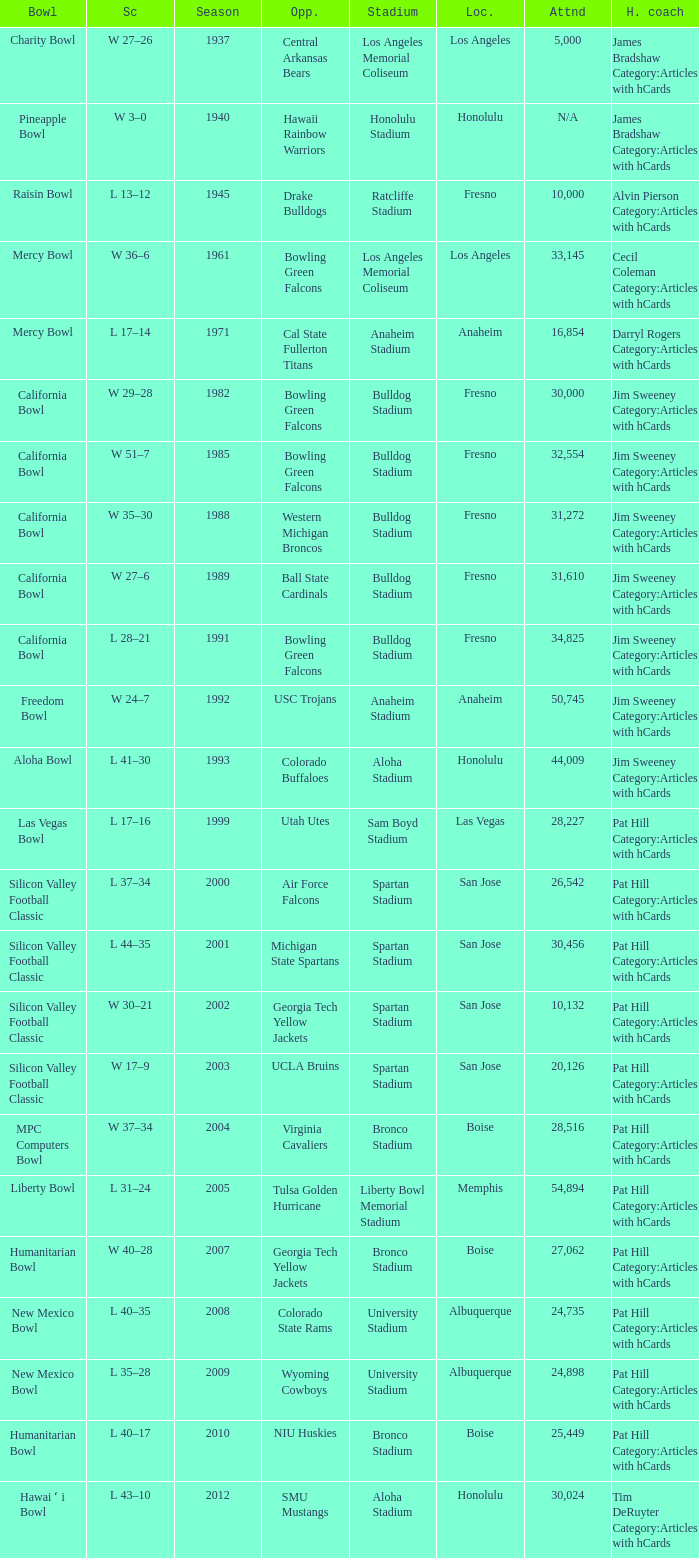Where was the California bowl played with 30,000 attending? Fresno. I'm looking to parse the entire table for insights. Could you assist me with that? {'header': ['Bowl', 'Sc', 'Season', 'Opp.', 'Stadium', 'Loc.', 'Attnd', 'H. coach'], 'rows': [['Charity Bowl', 'W 27–26', '1937', 'Central Arkansas Bears', 'Los Angeles Memorial Coliseum', 'Los Angeles', '5,000', 'James Bradshaw Category:Articles with hCards'], ['Pineapple Bowl', 'W 3–0', '1940', 'Hawaii Rainbow Warriors', 'Honolulu Stadium', 'Honolulu', 'N/A', 'James Bradshaw Category:Articles with hCards'], ['Raisin Bowl', 'L 13–12', '1945', 'Drake Bulldogs', 'Ratcliffe Stadium', 'Fresno', '10,000', 'Alvin Pierson Category:Articles with hCards'], ['Mercy Bowl', 'W 36–6', '1961', 'Bowling Green Falcons', 'Los Angeles Memorial Coliseum', 'Los Angeles', '33,145', 'Cecil Coleman Category:Articles with hCards'], ['Mercy Bowl', 'L 17–14', '1971', 'Cal State Fullerton Titans', 'Anaheim Stadium', 'Anaheim', '16,854', 'Darryl Rogers Category:Articles with hCards'], ['California Bowl', 'W 29–28', '1982', 'Bowling Green Falcons', 'Bulldog Stadium', 'Fresno', '30,000', 'Jim Sweeney Category:Articles with hCards'], ['California Bowl', 'W 51–7', '1985', 'Bowling Green Falcons', 'Bulldog Stadium', 'Fresno', '32,554', 'Jim Sweeney Category:Articles with hCards'], ['California Bowl', 'W 35–30', '1988', 'Western Michigan Broncos', 'Bulldog Stadium', 'Fresno', '31,272', 'Jim Sweeney Category:Articles with hCards'], ['California Bowl', 'W 27–6', '1989', 'Ball State Cardinals', 'Bulldog Stadium', 'Fresno', '31,610', 'Jim Sweeney Category:Articles with hCards'], ['California Bowl', 'L 28–21', '1991', 'Bowling Green Falcons', 'Bulldog Stadium', 'Fresno', '34,825', 'Jim Sweeney Category:Articles with hCards'], ['Freedom Bowl', 'W 24–7', '1992', 'USC Trojans', 'Anaheim Stadium', 'Anaheim', '50,745', 'Jim Sweeney Category:Articles with hCards'], ['Aloha Bowl', 'L 41–30', '1993', 'Colorado Buffaloes', 'Aloha Stadium', 'Honolulu', '44,009', 'Jim Sweeney Category:Articles with hCards'], ['Las Vegas Bowl', 'L 17–16', '1999', 'Utah Utes', 'Sam Boyd Stadium', 'Las Vegas', '28,227', 'Pat Hill Category:Articles with hCards'], ['Silicon Valley Football Classic', 'L 37–34', '2000', 'Air Force Falcons', 'Spartan Stadium', 'San Jose', '26,542', 'Pat Hill Category:Articles with hCards'], ['Silicon Valley Football Classic', 'L 44–35', '2001', 'Michigan State Spartans', 'Spartan Stadium', 'San Jose', '30,456', 'Pat Hill Category:Articles with hCards'], ['Silicon Valley Football Classic', 'W 30–21', '2002', 'Georgia Tech Yellow Jackets', 'Spartan Stadium', 'San Jose', '10,132', 'Pat Hill Category:Articles with hCards'], ['Silicon Valley Football Classic', 'W 17–9', '2003', 'UCLA Bruins', 'Spartan Stadium', 'San Jose', '20,126', 'Pat Hill Category:Articles with hCards'], ['MPC Computers Bowl', 'W 37–34', '2004', 'Virginia Cavaliers', 'Bronco Stadium', 'Boise', '28,516', 'Pat Hill Category:Articles with hCards'], ['Liberty Bowl', 'L 31–24', '2005', 'Tulsa Golden Hurricane', 'Liberty Bowl Memorial Stadium', 'Memphis', '54,894', 'Pat Hill Category:Articles with hCards'], ['Humanitarian Bowl', 'W 40–28', '2007', 'Georgia Tech Yellow Jackets', 'Bronco Stadium', 'Boise', '27,062', 'Pat Hill Category:Articles with hCards'], ['New Mexico Bowl', 'L 40–35', '2008', 'Colorado State Rams', 'University Stadium', 'Albuquerque', '24,735', 'Pat Hill Category:Articles with hCards'], ['New Mexico Bowl', 'L 35–28', '2009', 'Wyoming Cowboys', 'University Stadium', 'Albuquerque', '24,898', 'Pat Hill Category:Articles with hCards'], ['Humanitarian Bowl', 'L 40–17', '2010', 'NIU Huskies', 'Bronco Stadium', 'Boise', '25,449', 'Pat Hill Category:Articles with hCards'], ['Hawai ʻ i Bowl', 'L 43–10', '2012', 'SMU Mustangs', 'Aloha Stadium', 'Honolulu', '30,024', 'Tim DeRuyter Category:Articles with hCards']]} 